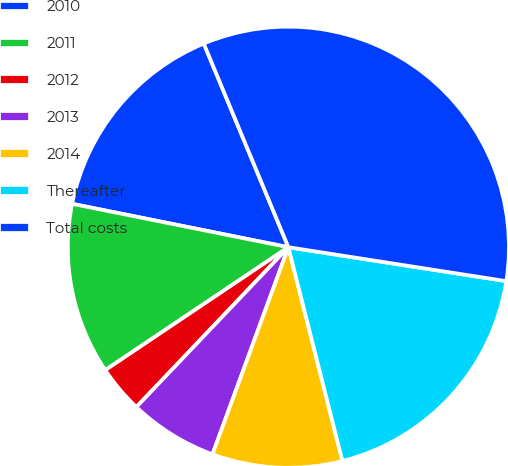Convert chart to OTSL. <chart><loc_0><loc_0><loc_500><loc_500><pie_chart><fcel>2010<fcel>2011<fcel>2012<fcel>2013<fcel>2014<fcel>Thereafter<fcel>Total costs<nl><fcel>15.58%<fcel>12.56%<fcel>3.49%<fcel>6.51%<fcel>9.53%<fcel>18.6%<fcel>33.72%<nl></chart> 